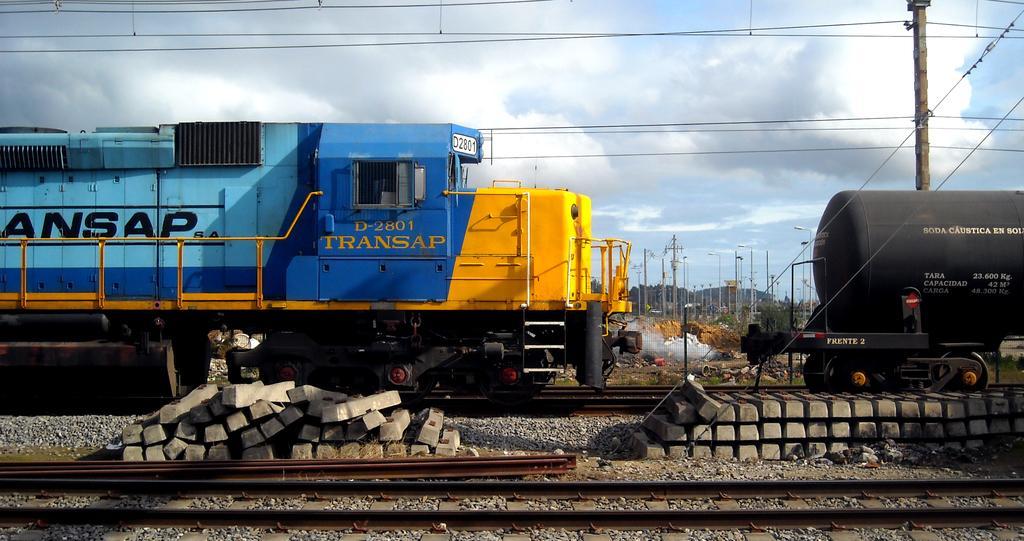Can you describe this image briefly? In the center of the image we can see a locomotive placed on the track. On the right side of the image we can see a tanker wagon on track. At the bottom of the image we can see metal poles and some concrete blocks placed on the ground. In the background, we can see the poles with cable, group of trees and the sky. 